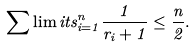<formula> <loc_0><loc_0><loc_500><loc_500>\sum \lim i t s _ { i = 1 } ^ { n } \frac { 1 } { r _ { i } + 1 } \leq \frac { n } { 2 } .</formula> 